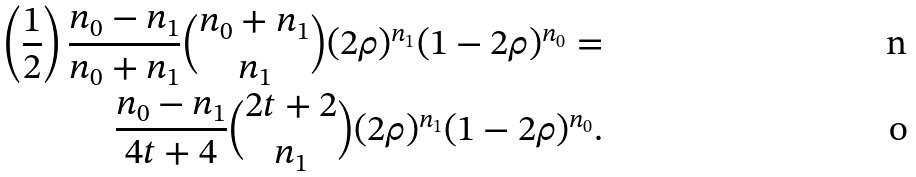Convert formula to latex. <formula><loc_0><loc_0><loc_500><loc_500>\left ( \frac { 1 } { 2 } \right ) \frac { n _ { 0 } - n _ { 1 } } { n _ { 0 } + n _ { 1 } } \binom { n _ { 0 } + n _ { 1 } } { n _ { 1 } } ( 2 \rho ) ^ { n _ { 1 } } ( 1 - 2 \rho ) ^ { n _ { 0 } } = \\ \frac { n _ { 0 } - n _ { 1 } } { 4 t + 4 } \binom { 2 t + 2 } { n _ { 1 } } ( 2 \rho ) ^ { n _ { 1 } } ( 1 - 2 \rho ) ^ { n _ { 0 } } .</formula> 